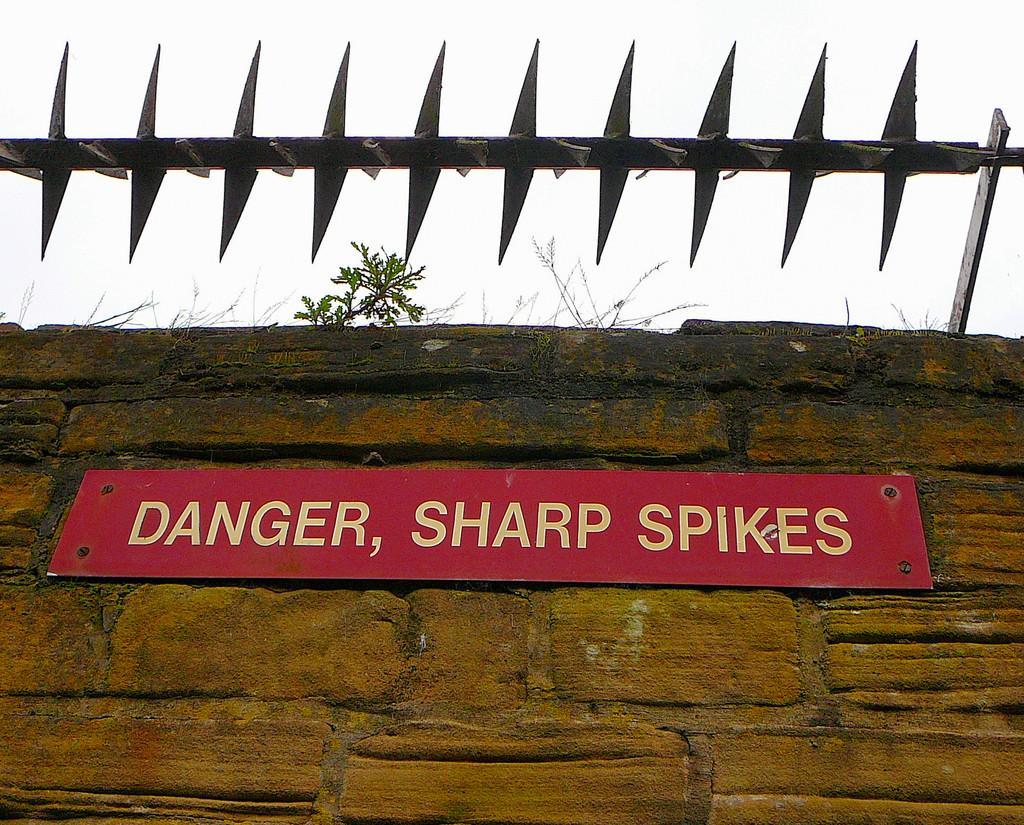In one or two sentences, can you explain what this image depicts? In the image we can see picket fence, stone wall, board and on the board there is a text, plant and white sky. 